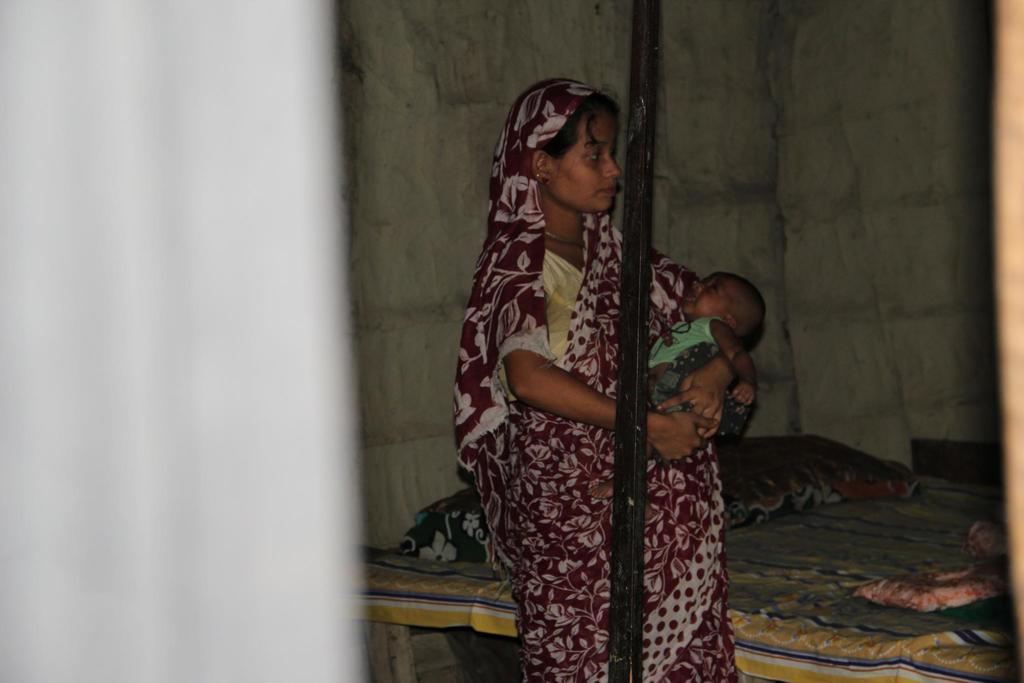What is the main subject of the image? There is a woman in the image. What is the woman doing in the image? The woman is standing and holding a baby in her hands. Can you describe any other objects or structures in the image? There appears to be a pole in the image, as well as a bed. What is the condition of the bed in the image? The bed is covered with a bed sheet, and there are pillows visible in the image. What type of books can be seen on the bed in the image? There are no books visible in the image; it only shows a woman holding a baby, a pole, and a bed with pillows. 